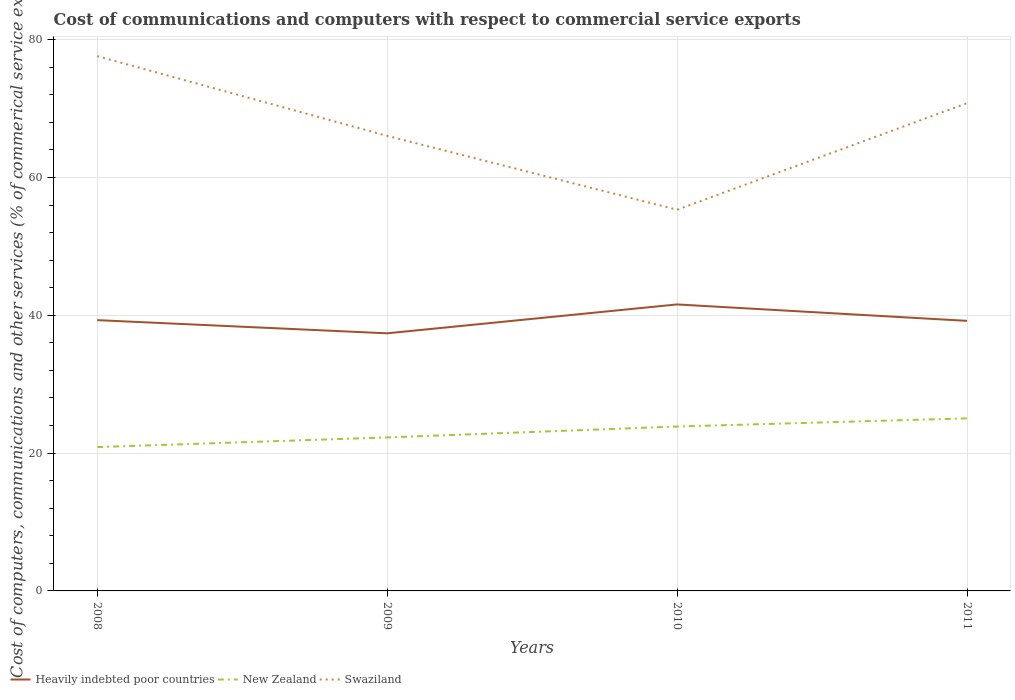How many different coloured lines are there?
Provide a short and direct response. 3. Is the number of lines equal to the number of legend labels?
Offer a terse response. Yes. Across all years, what is the maximum cost of communications and computers in New Zealand?
Make the answer very short. 20.87. In which year was the cost of communications and computers in New Zealand maximum?
Your response must be concise. 2008. What is the total cost of communications and computers in Heavily indebted poor countries in the graph?
Your answer should be compact. 1.91. What is the difference between the highest and the second highest cost of communications and computers in Heavily indebted poor countries?
Your answer should be very brief. 4.19. How many lines are there?
Ensure brevity in your answer.  3. How many years are there in the graph?
Offer a very short reply. 4. Are the values on the major ticks of Y-axis written in scientific E-notation?
Offer a terse response. No. Does the graph contain any zero values?
Your response must be concise. No. What is the title of the graph?
Your answer should be very brief. Cost of communications and computers with respect to commercial service exports. What is the label or title of the Y-axis?
Give a very brief answer. Cost of computers, communications and other services (% of commerical service exports). What is the Cost of computers, communications and other services (% of commerical service exports) in Heavily indebted poor countries in 2008?
Give a very brief answer. 39.3. What is the Cost of computers, communications and other services (% of commerical service exports) in New Zealand in 2008?
Make the answer very short. 20.87. What is the Cost of computers, communications and other services (% of commerical service exports) of Swaziland in 2008?
Give a very brief answer. 77.61. What is the Cost of computers, communications and other services (% of commerical service exports) of Heavily indebted poor countries in 2009?
Make the answer very short. 37.39. What is the Cost of computers, communications and other services (% of commerical service exports) of New Zealand in 2009?
Provide a succinct answer. 22.28. What is the Cost of computers, communications and other services (% of commerical service exports) in Swaziland in 2009?
Offer a terse response. 66.04. What is the Cost of computers, communications and other services (% of commerical service exports) of Heavily indebted poor countries in 2010?
Offer a very short reply. 41.58. What is the Cost of computers, communications and other services (% of commerical service exports) in New Zealand in 2010?
Your answer should be very brief. 23.86. What is the Cost of computers, communications and other services (% of commerical service exports) of Swaziland in 2010?
Ensure brevity in your answer.  55.32. What is the Cost of computers, communications and other services (% of commerical service exports) of Heavily indebted poor countries in 2011?
Offer a very short reply. 39.19. What is the Cost of computers, communications and other services (% of commerical service exports) of New Zealand in 2011?
Keep it short and to the point. 25.04. What is the Cost of computers, communications and other services (% of commerical service exports) in Swaziland in 2011?
Make the answer very short. 70.79. Across all years, what is the maximum Cost of computers, communications and other services (% of commerical service exports) in Heavily indebted poor countries?
Offer a terse response. 41.58. Across all years, what is the maximum Cost of computers, communications and other services (% of commerical service exports) of New Zealand?
Your response must be concise. 25.04. Across all years, what is the maximum Cost of computers, communications and other services (% of commerical service exports) of Swaziland?
Your answer should be compact. 77.61. Across all years, what is the minimum Cost of computers, communications and other services (% of commerical service exports) in Heavily indebted poor countries?
Ensure brevity in your answer.  37.39. Across all years, what is the minimum Cost of computers, communications and other services (% of commerical service exports) in New Zealand?
Keep it short and to the point. 20.87. Across all years, what is the minimum Cost of computers, communications and other services (% of commerical service exports) in Swaziland?
Make the answer very short. 55.32. What is the total Cost of computers, communications and other services (% of commerical service exports) of Heavily indebted poor countries in the graph?
Ensure brevity in your answer.  157.45. What is the total Cost of computers, communications and other services (% of commerical service exports) of New Zealand in the graph?
Keep it short and to the point. 92.05. What is the total Cost of computers, communications and other services (% of commerical service exports) in Swaziland in the graph?
Offer a very short reply. 269.75. What is the difference between the Cost of computers, communications and other services (% of commerical service exports) in Heavily indebted poor countries in 2008 and that in 2009?
Provide a short and direct response. 1.91. What is the difference between the Cost of computers, communications and other services (% of commerical service exports) of New Zealand in 2008 and that in 2009?
Ensure brevity in your answer.  -1.4. What is the difference between the Cost of computers, communications and other services (% of commerical service exports) in Swaziland in 2008 and that in 2009?
Your response must be concise. 11.57. What is the difference between the Cost of computers, communications and other services (% of commerical service exports) of Heavily indebted poor countries in 2008 and that in 2010?
Keep it short and to the point. -2.28. What is the difference between the Cost of computers, communications and other services (% of commerical service exports) of New Zealand in 2008 and that in 2010?
Your answer should be compact. -2.99. What is the difference between the Cost of computers, communications and other services (% of commerical service exports) of Swaziland in 2008 and that in 2010?
Your answer should be compact. 22.3. What is the difference between the Cost of computers, communications and other services (% of commerical service exports) in Heavily indebted poor countries in 2008 and that in 2011?
Keep it short and to the point. 0.1. What is the difference between the Cost of computers, communications and other services (% of commerical service exports) in New Zealand in 2008 and that in 2011?
Your response must be concise. -4.17. What is the difference between the Cost of computers, communications and other services (% of commerical service exports) of Swaziland in 2008 and that in 2011?
Ensure brevity in your answer.  6.83. What is the difference between the Cost of computers, communications and other services (% of commerical service exports) in Heavily indebted poor countries in 2009 and that in 2010?
Make the answer very short. -4.19. What is the difference between the Cost of computers, communications and other services (% of commerical service exports) in New Zealand in 2009 and that in 2010?
Provide a short and direct response. -1.58. What is the difference between the Cost of computers, communications and other services (% of commerical service exports) of Swaziland in 2009 and that in 2010?
Your answer should be very brief. 10.72. What is the difference between the Cost of computers, communications and other services (% of commerical service exports) of Heavily indebted poor countries in 2009 and that in 2011?
Ensure brevity in your answer.  -1.81. What is the difference between the Cost of computers, communications and other services (% of commerical service exports) of New Zealand in 2009 and that in 2011?
Your response must be concise. -2.77. What is the difference between the Cost of computers, communications and other services (% of commerical service exports) of Swaziland in 2009 and that in 2011?
Your response must be concise. -4.75. What is the difference between the Cost of computers, communications and other services (% of commerical service exports) of Heavily indebted poor countries in 2010 and that in 2011?
Offer a terse response. 2.38. What is the difference between the Cost of computers, communications and other services (% of commerical service exports) of New Zealand in 2010 and that in 2011?
Provide a succinct answer. -1.18. What is the difference between the Cost of computers, communications and other services (% of commerical service exports) in Swaziland in 2010 and that in 2011?
Give a very brief answer. -15.47. What is the difference between the Cost of computers, communications and other services (% of commerical service exports) in Heavily indebted poor countries in 2008 and the Cost of computers, communications and other services (% of commerical service exports) in New Zealand in 2009?
Provide a short and direct response. 17.02. What is the difference between the Cost of computers, communications and other services (% of commerical service exports) of Heavily indebted poor countries in 2008 and the Cost of computers, communications and other services (% of commerical service exports) of Swaziland in 2009?
Ensure brevity in your answer.  -26.74. What is the difference between the Cost of computers, communications and other services (% of commerical service exports) of New Zealand in 2008 and the Cost of computers, communications and other services (% of commerical service exports) of Swaziland in 2009?
Ensure brevity in your answer.  -45.17. What is the difference between the Cost of computers, communications and other services (% of commerical service exports) of Heavily indebted poor countries in 2008 and the Cost of computers, communications and other services (% of commerical service exports) of New Zealand in 2010?
Give a very brief answer. 15.44. What is the difference between the Cost of computers, communications and other services (% of commerical service exports) in Heavily indebted poor countries in 2008 and the Cost of computers, communications and other services (% of commerical service exports) in Swaziland in 2010?
Keep it short and to the point. -16.02. What is the difference between the Cost of computers, communications and other services (% of commerical service exports) of New Zealand in 2008 and the Cost of computers, communications and other services (% of commerical service exports) of Swaziland in 2010?
Ensure brevity in your answer.  -34.44. What is the difference between the Cost of computers, communications and other services (% of commerical service exports) of Heavily indebted poor countries in 2008 and the Cost of computers, communications and other services (% of commerical service exports) of New Zealand in 2011?
Ensure brevity in your answer.  14.25. What is the difference between the Cost of computers, communications and other services (% of commerical service exports) in Heavily indebted poor countries in 2008 and the Cost of computers, communications and other services (% of commerical service exports) in Swaziland in 2011?
Your response must be concise. -31.49. What is the difference between the Cost of computers, communications and other services (% of commerical service exports) of New Zealand in 2008 and the Cost of computers, communications and other services (% of commerical service exports) of Swaziland in 2011?
Ensure brevity in your answer.  -49.91. What is the difference between the Cost of computers, communications and other services (% of commerical service exports) of Heavily indebted poor countries in 2009 and the Cost of computers, communications and other services (% of commerical service exports) of New Zealand in 2010?
Your response must be concise. 13.53. What is the difference between the Cost of computers, communications and other services (% of commerical service exports) of Heavily indebted poor countries in 2009 and the Cost of computers, communications and other services (% of commerical service exports) of Swaziland in 2010?
Keep it short and to the point. -17.93. What is the difference between the Cost of computers, communications and other services (% of commerical service exports) of New Zealand in 2009 and the Cost of computers, communications and other services (% of commerical service exports) of Swaziland in 2010?
Your answer should be very brief. -33.04. What is the difference between the Cost of computers, communications and other services (% of commerical service exports) in Heavily indebted poor countries in 2009 and the Cost of computers, communications and other services (% of commerical service exports) in New Zealand in 2011?
Your answer should be compact. 12.34. What is the difference between the Cost of computers, communications and other services (% of commerical service exports) in Heavily indebted poor countries in 2009 and the Cost of computers, communications and other services (% of commerical service exports) in Swaziland in 2011?
Provide a succinct answer. -33.4. What is the difference between the Cost of computers, communications and other services (% of commerical service exports) in New Zealand in 2009 and the Cost of computers, communications and other services (% of commerical service exports) in Swaziland in 2011?
Make the answer very short. -48.51. What is the difference between the Cost of computers, communications and other services (% of commerical service exports) in Heavily indebted poor countries in 2010 and the Cost of computers, communications and other services (% of commerical service exports) in New Zealand in 2011?
Your answer should be very brief. 16.53. What is the difference between the Cost of computers, communications and other services (% of commerical service exports) in Heavily indebted poor countries in 2010 and the Cost of computers, communications and other services (% of commerical service exports) in Swaziland in 2011?
Ensure brevity in your answer.  -29.21. What is the difference between the Cost of computers, communications and other services (% of commerical service exports) of New Zealand in 2010 and the Cost of computers, communications and other services (% of commerical service exports) of Swaziland in 2011?
Provide a succinct answer. -46.93. What is the average Cost of computers, communications and other services (% of commerical service exports) of Heavily indebted poor countries per year?
Provide a succinct answer. 39.36. What is the average Cost of computers, communications and other services (% of commerical service exports) in New Zealand per year?
Your response must be concise. 23.01. What is the average Cost of computers, communications and other services (% of commerical service exports) of Swaziland per year?
Your response must be concise. 67.44. In the year 2008, what is the difference between the Cost of computers, communications and other services (% of commerical service exports) in Heavily indebted poor countries and Cost of computers, communications and other services (% of commerical service exports) in New Zealand?
Make the answer very short. 18.43. In the year 2008, what is the difference between the Cost of computers, communications and other services (% of commerical service exports) in Heavily indebted poor countries and Cost of computers, communications and other services (% of commerical service exports) in Swaziland?
Your response must be concise. -38.31. In the year 2008, what is the difference between the Cost of computers, communications and other services (% of commerical service exports) of New Zealand and Cost of computers, communications and other services (% of commerical service exports) of Swaziland?
Provide a short and direct response. -56.74. In the year 2009, what is the difference between the Cost of computers, communications and other services (% of commerical service exports) in Heavily indebted poor countries and Cost of computers, communications and other services (% of commerical service exports) in New Zealand?
Provide a succinct answer. 15.11. In the year 2009, what is the difference between the Cost of computers, communications and other services (% of commerical service exports) of Heavily indebted poor countries and Cost of computers, communications and other services (% of commerical service exports) of Swaziland?
Give a very brief answer. -28.66. In the year 2009, what is the difference between the Cost of computers, communications and other services (% of commerical service exports) of New Zealand and Cost of computers, communications and other services (% of commerical service exports) of Swaziland?
Keep it short and to the point. -43.76. In the year 2010, what is the difference between the Cost of computers, communications and other services (% of commerical service exports) in Heavily indebted poor countries and Cost of computers, communications and other services (% of commerical service exports) in New Zealand?
Make the answer very short. 17.72. In the year 2010, what is the difference between the Cost of computers, communications and other services (% of commerical service exports) in Heavily indebted poor countries and Cost of computers, communications and other services (% of commerical service exports) in Swaziland?
Give a very brief answer. -13.74. In the year 2010, what is the difference between the Cost of computers, communications and other services (% of commerical service exports) of New Zealand and Cost of computers, communications and other services (% of commerical service exports) of Swaziland?
Provide a short and direct response. -31.46. In the year 2011, what is the difference between the Cost of computers, communications and other services (% of commerical service exports) of Heavily indebted poor countries and Cost of computers, communications and other services (% of commerical service exports) of New Zealand?
Your answer should be compact. 14.15. In the year 2011, what is the difference between the Cost of computers, communications and other services (% of commerical service exports) of Heavily indebted poor countries and Cost of computers, communications and other services (% of commerical service exports) of Swaziland?
Your answer should be compact. -31.59. In the year 2011, what is the difference between the Cost of computers, communications and other services (% of commerical service exports) in New Zealand and Cost of computers, communications and other services (% of commerical service exports) in Swaziland?
Keep it short and to the point. -45.74. What is the ratio of the Cost of computers, communications and other services (% of commerical service exports) of Heavily indebted poor countries in 2008 to that in 2009?
Your answer should be compact. 1.05. What is the ratio of the Cost of computers, communications and other services (% of commerical service exports) of New Zealand in 2008 to that in 2009?
Ensure brevity in your answer.  0.94. What is the ratio of the Cost of computers, communications and other services (% of commerical service exports) of Swaziland in 2008 to that in 2009?
Ensure brevity in your answer.  1.18. What is the ratio of the Cost of computers, communications and other services (% of commerical service exports) in Heavily indebted poor countries in 2008 to that in 2010?
Your answer should be very brief. 0.95. What is the ratio of the Cost of computers, communications and other services (% of commerical service exports) in New Zealand in 2008 to that in 2010?
Offer a terse response. 0.87. What is the ratio of the Cost of computers, communications and other services (% of commerical service exports) of Swaziland in 2008 to that in 2010?
Keep it short and to the point. 1.4. What is the ratio of the Cost of computers, communications and other services (% of commerical service exports) in Heavily indebted poor countries in 2008 to that in 2011?
Give a very brief answer. 1. What is the ratio of the Cost of computers, communications and other services (% of commerical service exports) in New Zealand in 2008 to that in 2011?
Ensure brevity in your answer.  0.83. What is the ratio of the Cost of computers, communications and other services (% of commerical service exports) in Swaziland in 2008 to that in 2011?
Keep it short and to the point. 1.1. What is the ratio of the Cost of computers, communications and other services (% of commerical service exports) in Heavily indebted poor countries in 2009 to that in 2010?
Your answer should be very brief. 0.9. What is the ratio of the Cost of computers, communications and other services (% of commerical service exports) in New Zealand in 2009 to that in 2010?
Give a very brief answer. 0.93. What is the ratio of the Cost of computers, communications and other services (% of commerical service exports) of Swaziland in 2009 to that in 2010?
Keep it short and to the point. 1.19. What is the ratio of the Cost of computers, communications and other services (% of commerical service exports) of Heavily indebted poor countries in 2009 to that in 2011?
Offer a very short reply. 0.95. What is the ratio of the Cost of computers, communications and other services (% of commerical service exports) in New Zealand in 2009 to that in 2011?
Ensure brevity in your answer.  0.89. What is the ratio of the Cost of computers, communications and other services (% of commerical service exports) of Swaziland in 2009 to that in 2011?
Your response must be concise. 0.93. What is the ratio of the Cost of computers, communications and other services (% of commerical service exports) in Heavily indebted poor countries in 2010 to that in 2011?
Ensure brevity in your answer.  1.06. What is the ratio of the Cost of computers, communications and other services (% of commerical service exports) of New Zealand in 2010 to that in 2011?
Provide a succinct answer. 0.95. What is the ratio of the Cost of computers, communications and other services (% of commerical service exports) in Swaziland in 2010 to that in 2011?
Give a very brief answer. 0.78. What is the difference between the highest and the second highest Cost of computers, communications and other services (% of commerical service exports) in Heavily indebted poor countries?
Offer a very short reply. 2.28. What is the difference between the highest and the second highest Cost of computers, communications and other services (% of commerical service exports) of New Zealand?
Provide a short and direct response. 1.18. What is the difference between the highest and the second highest Cost of computers, communications and other services (% of commerical service exports) in Swaziland?
Your response must be concise. 6.83. What is the difference between the highest and the lowest Cost of computers, communications and other services (% of commerical service exports) in Heavily indebted poor countries?
Your response must be concise. 4.19. What is the difference between the highest and the lowest Cost of computers, communications and other services (% of commerical service exports) in New Zealand?
Provide a succinct answer. 4.17. What is the difference between the highest and the lowest Cost of computers, communications and other services (% of commerical service exports) of Swaziland?
Your answer should be compact. 22.3. 